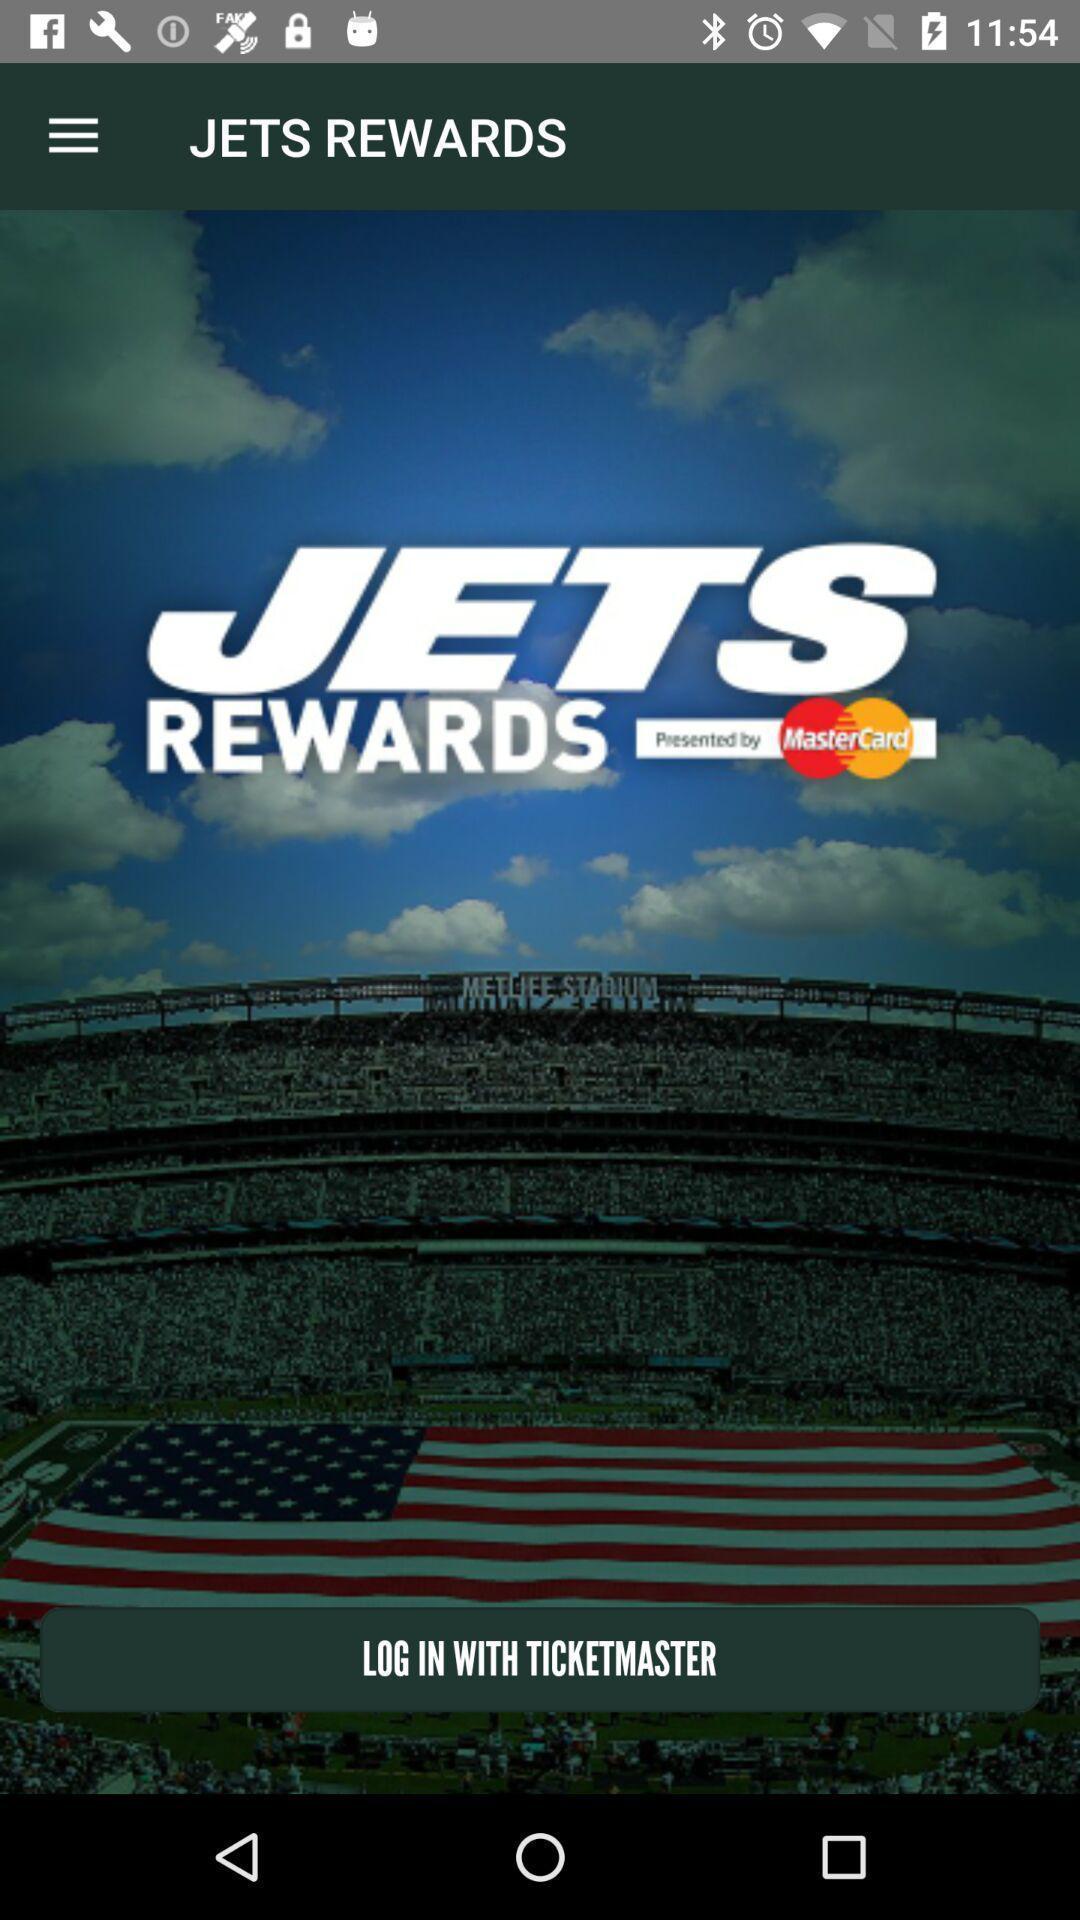Tell me about the visual elements in this screen capture. Welcome page with log in option. 